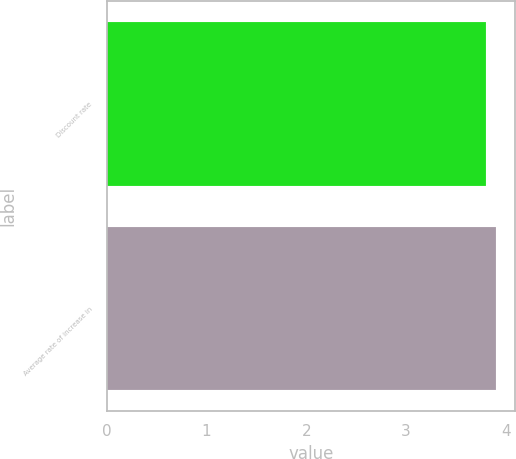Convert chart to OTSL. <chart><loc_0><loc_0><loc_500><loc_500><bar_chart><fcel>Discount rate<fcel>Average rate of increase in<nl><fcel>3.8<fcel>3.9<nl></chart> 